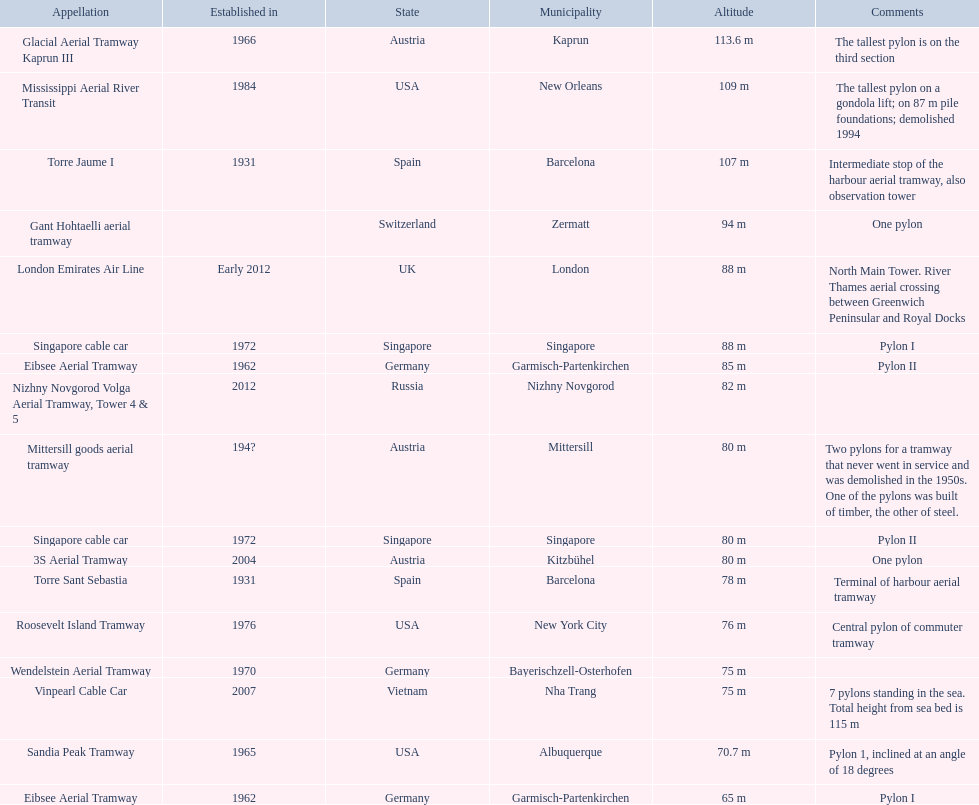How many aerial lift pylon's on the list are located in the usa? Mississippi Aerial River Transit, Roosevelt Island Tramway, Sandia Peak Tramway. Of the pylon's located in the usa how many were built after 1970? Mississippi Aerial River Transit, Roosevelt Island Tramway. Of the pylon's built after 1970 which is the tallest pylon on a gondola lift? Mississippi Aerial River Transit. How many meters is the tallest pylon on a gondola lift? 109 m. 